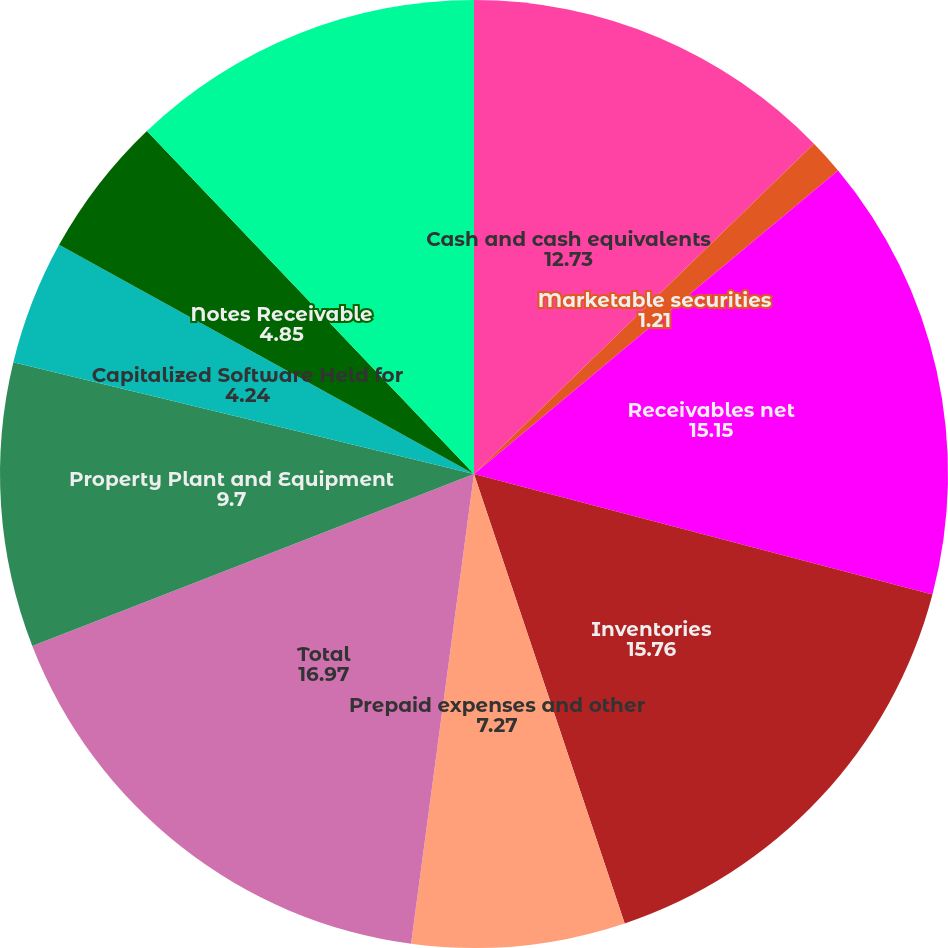<chart> <loc_0><loc_0><loc_500><loc_500><pie_chart><fcel>Cash and cash equivalents<fcel>Marketable securities<fcel>Receivables net<fcel>Inventories<fcel>Prepaid expenses and other<fcel>Total<fcel>Property Plant and Equipment<fcel>Capitalized Software Held for<fcel>Notes Receivable<fcel>Goodwill<nl><fcel>12.73%<fcel>1.21%<fcel>15.15%<fcel>15.76%<fcel>7.27%<fcel>16.97%<fcel>9.7%<fcel>4.24%<fcel>4.85%<fcel>12.12%<nl></chart> 